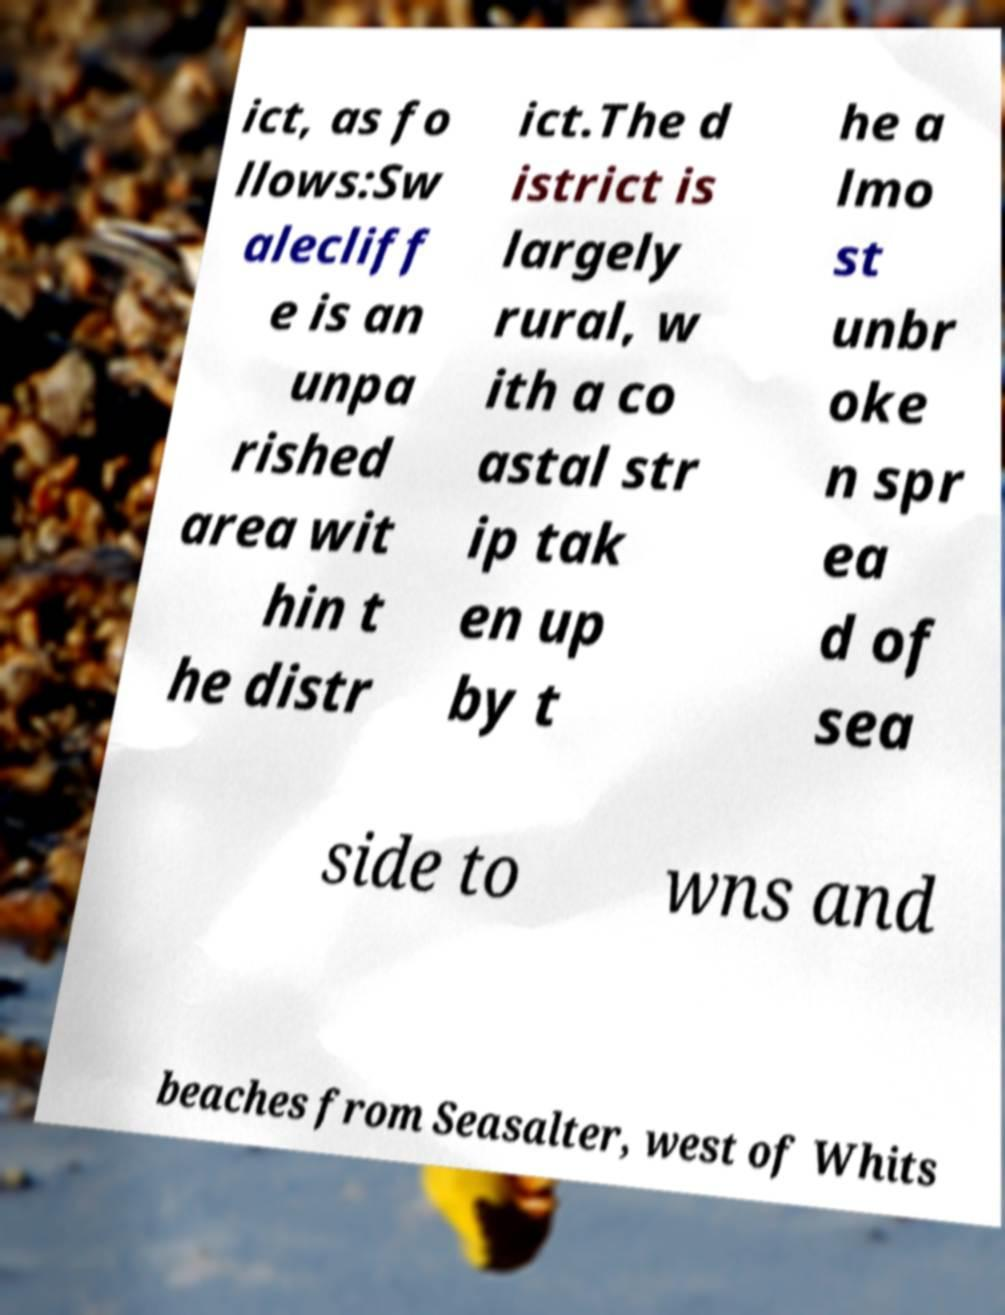Could you extract and type out the text from this image? ict, as fo llows:Sw alecliff e is an unpa rished area wit hin t he distr ict.The d istrict is largely rural, w ith a co astal str ip tak en up by t he a lmo st unbr oke n spr ea d of sea side to wns and beaches from Seasalter, west of Whits 